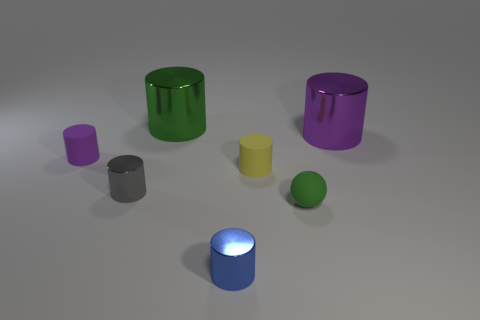Subtract all large purple cylinders. How many cylinders are left? 5 Subtract 2 cylinders. How many cylinders are left? 4 Add 3 big brown metal spheres. How many objects exist? 10 Subtract all cylinders. How many objects are left? 1 Subtract all gray cylinders. Subtract all purple balls. How many cylinders are left? 5 Subtract all gray balls. How many yellow cylinders are left? 1 Subtract all tiny gray rubber blocks. Subtract all small purple matte objects. How many objects are left? 6 Add 4 large purple metallic objects. How many large purple metallic objects are left? 5 Add 2 gray cylinders. How many gray cylinders exist? 3 Subtract all yellow cylinders. How many cylinders are left? 5 